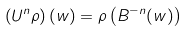<formula> <loc_0><loc_0><loc_500><loc_500>\left ( U ^ { n } \rho \right ) ( w ) = \rho \left ( B ^ { - n } ( w ) \right )</formula> 